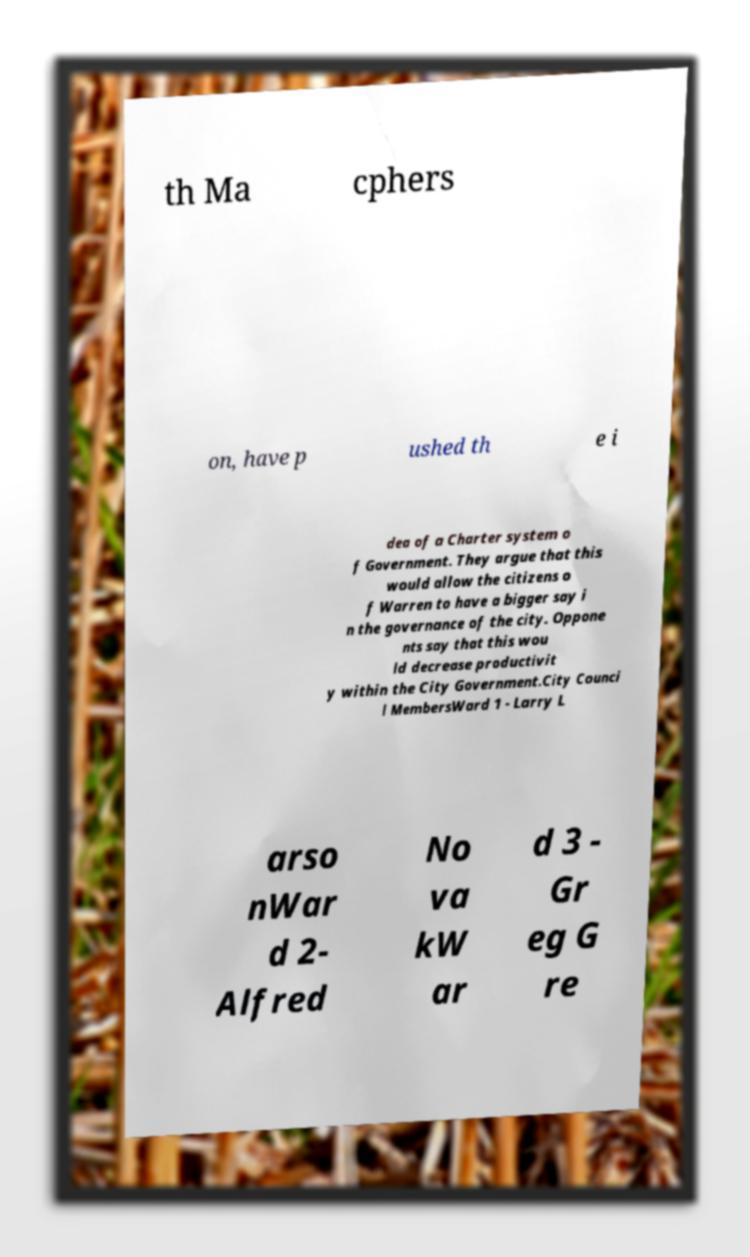I need the written content from this picture converted into text. Can you do that? th Ma cphers on, have p ushed th e i dea of a Charter system o f Government. They argue that this would allow the citizens o f Warren to have a bigger say i n the governance of the city. Oppone nts say that this wou ld decrease productivit y within the City Government.City Counci l MembersWard 1 - Larry L arso nWar d 2- Alfred No va kW ar d 3 - Gr eg G re 